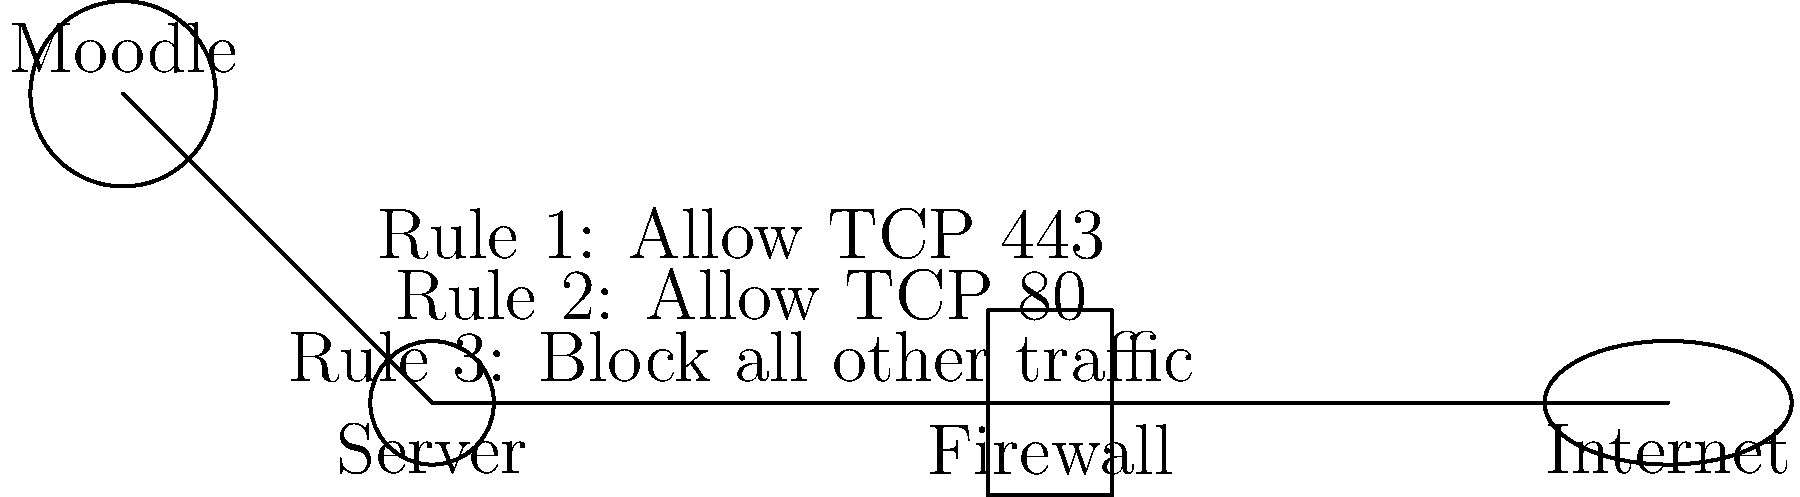Based on the firewall configuration diagram for the Moodle platform, which critical security measure is missing that could potentially expose the server to unauthorized access? To analyze the firewall configuration and identify the missing critical security measure, let's follow these steps:

1. Examine the current rules:
   - Rule 1 allows TCP port 443 (HTTPS)
   - Rule 2 allows TCP port 80 (HTTP)
   - Rule 3 blocks all other traffic

2. Consider the typical requirements for a Moodle server:
   - HTTPS access is necessary (covered by Rule 1)
   - HTTP access might be needed for redirects (covered by Rule 2)
   - Database access is required (usually MySQL or PostgreSQL)

3. Identify the missing element:
   - There's no rule allowing database traffic

4. Understand the implications:
   - Without a rule allowing database traffic, Moodle cannot communicate with its database
   - However, this also means the database port is not exposed to the internet, which is actually a security best practice

5. Recognize the real security issue:
   - The rules allow incoming traffic on ports 80 and 443 from any source
   - There's no restriction on the source IP addresses for these connections

6. Conclude the missing critical security measure:
   - The firewall lacks source IP restrictions for incoming web traffic
   - This could allow unauthorized access attempts from anywhere on the internet

Therefore, the missing critical security measure is source IP restrictions for incoming web traffic, which would limit access to authorized networks or IP ranges only.
Answer: Source IP restrictions for incoming web traffic 